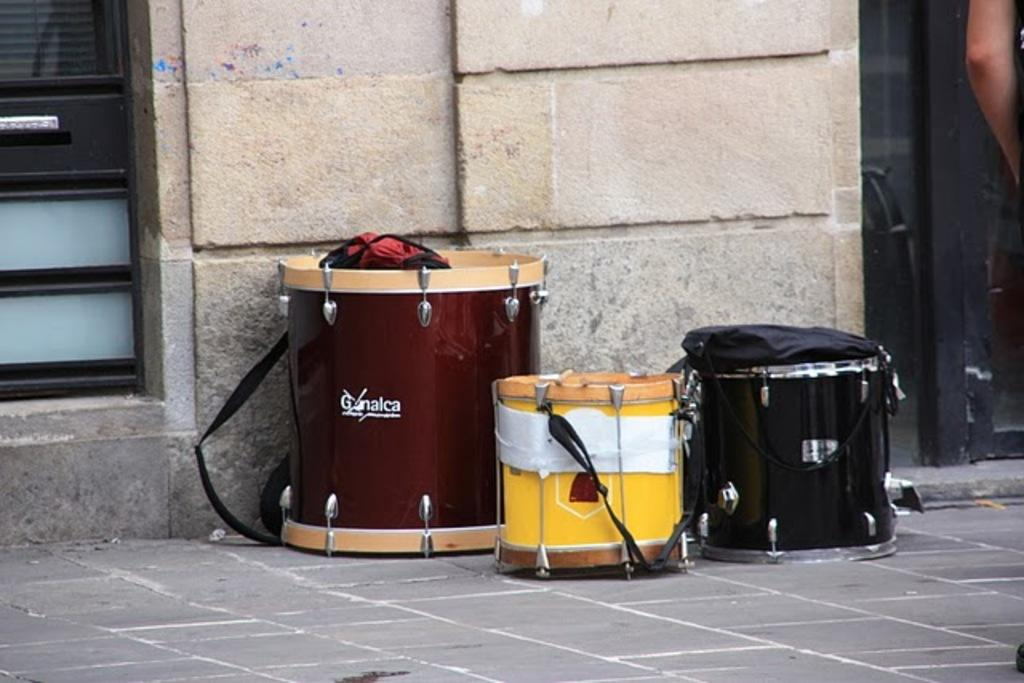Provide a one-sentence caption for the provided image. A couple of drums sit next to a building including one from Ganalca. 